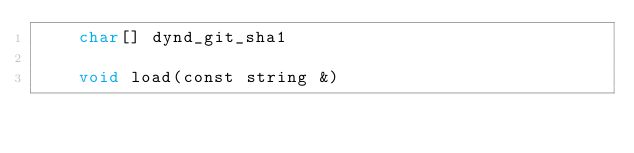Convert code to text. <code><loc_0><loc_0><loc_500><loc_500><_Cython_>    char[] dynd_git_sha1

    void load(const string &)
</code> 